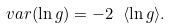Convert formula to latex. <formula><loc_0><loc_0><loc_500><loc_500>v a r ( \ln { g } ) = - 2 \ \langle \ln { g } \rangle .</formula> 